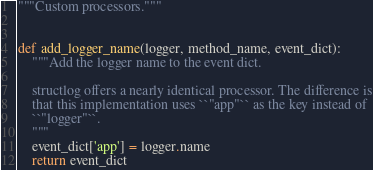Convert code to text. <code><loc_0><loc_0><loc_500><loc_500><_Python_>"""Custom processors."""


def add_logger_name(logger, method_name, event_dict):
    """Add the logger name to the event dict.

    structlog offers a nearly identical processor. The difference is
    that this implementation uses ``"app"`` as the key instead of
    ``"logger"``.
    """
    event_dict['app'] = logger.name
    return event_dict
</code> 